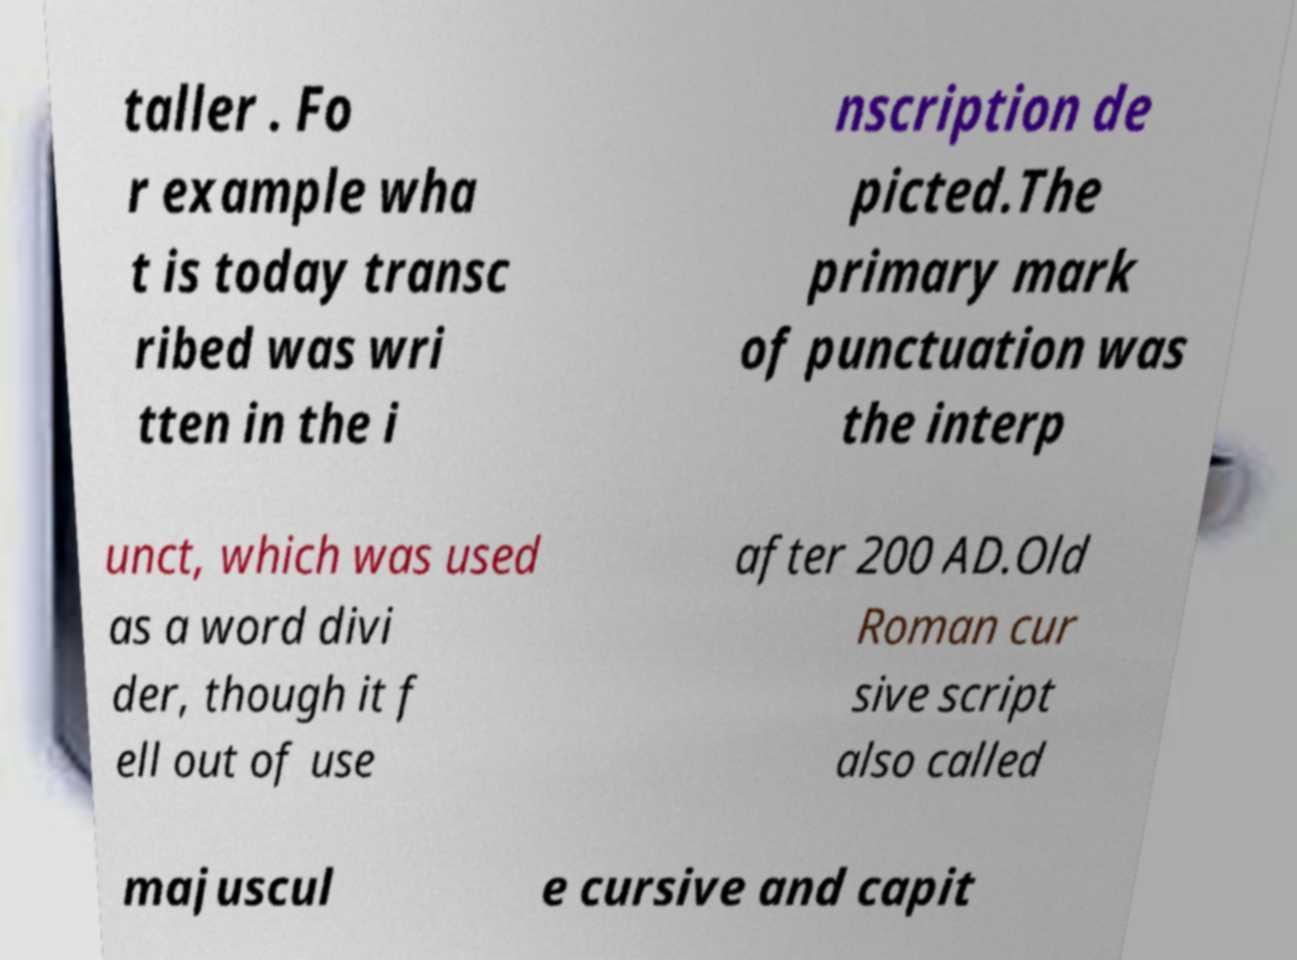What messages or text are displayed in this image? I need them in a readable, typed format. taller . Fo r example wha t is today transc ribed was wri tten in the i nscription de picted.The primary mark of punctuation was the interp unct, which was used as a word divi der, though it f ell out of use after 200 AD.Old Roman cur sive script also called majuscul e cursive and capit 